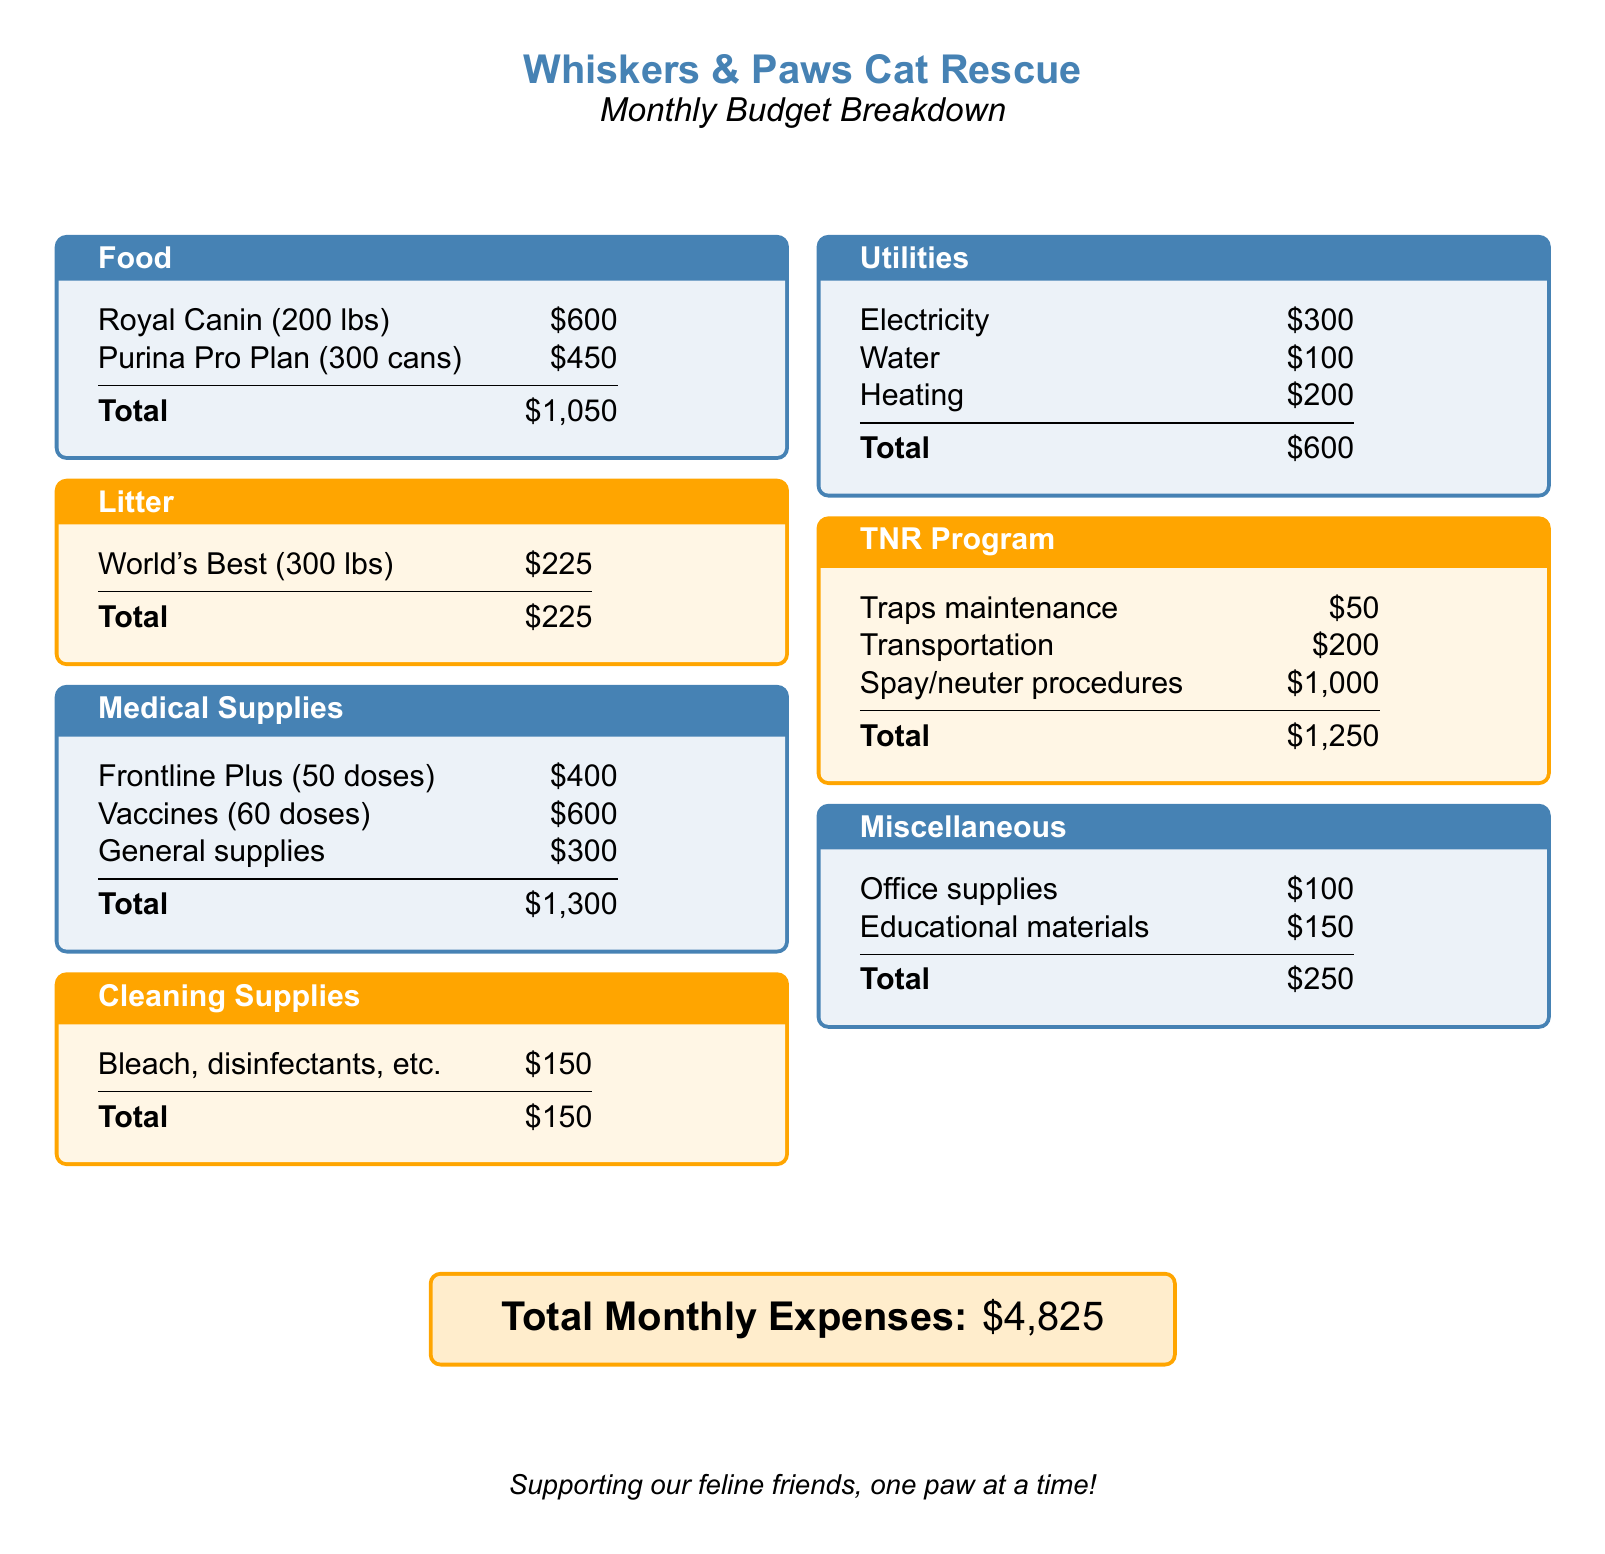What is the total monthly expense? The total monthly expense is provided at the end of the document, which sums up all categories.
Answer: $4,825 How much is spent on medical supplies? Medical supplies costs are detailed in one of the sections, adding up all individual line items.
Answer: $1,300 What is the cost of litter? The cost of litter is listed clearly in its own section.
Answer: $225 How much is allocated for food? The food expenses are outlined in the food section, and the total is specified.
Answer: $1,050 What is the cost for spay/neuter procedures? This expense is specifically listed under the TNR program section.
Answer: $1,000 What are the utilities expenses? Utilities encompass multiple costs, and their total is stated in the utilities section.
Answer: $600 How much is spent on cleaning supplies? The cleaning supplies cost is summarized in its own section with a total.
Answer: $150 Which brand of cat food has the highest expense? Looking at the food section, the costs indicate which brand has the highest total.
Answer: Royal Canin What is the total amount spent on the TNR program? The TNR program's total can be found by adding up its individual expenses listed in that section.
Answer: $1,250 